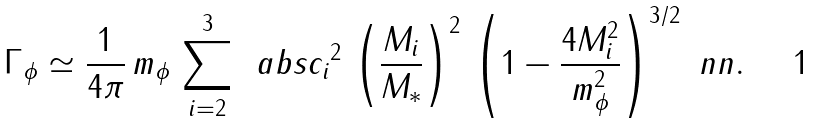Convert formula to latex. <formula><loc_0><loc_0><loc_500><loc_500>\Gamma _ { \phi } \simeq \frac { 1 } { 4 \pi } \, m _ { \phi } \, \sum _ { i = 2 } ^ { 3 } \, \ a b s { c _ { i } } ^ { 2 } \, \left ( \frac { M _ { i } } { M _ { * } } \right ) ^ { 2 } \, \left ( 1 - \frac { 4 M _ { i } ^ { 2 } } { m _ { \phi } ^ { 2 } } \right ) ^ { 3 / 2 } \ n n .</formula> 